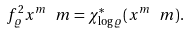Convert formula to latex. <formula><loc_0><loc_0><loc_500><loc_500>f _ { \varrho } ^ { 2 } x ^ { m } \ m = \chi _ { \log \varrho } ^ { * } ( x ^ { m } \ m ) .</formula> 